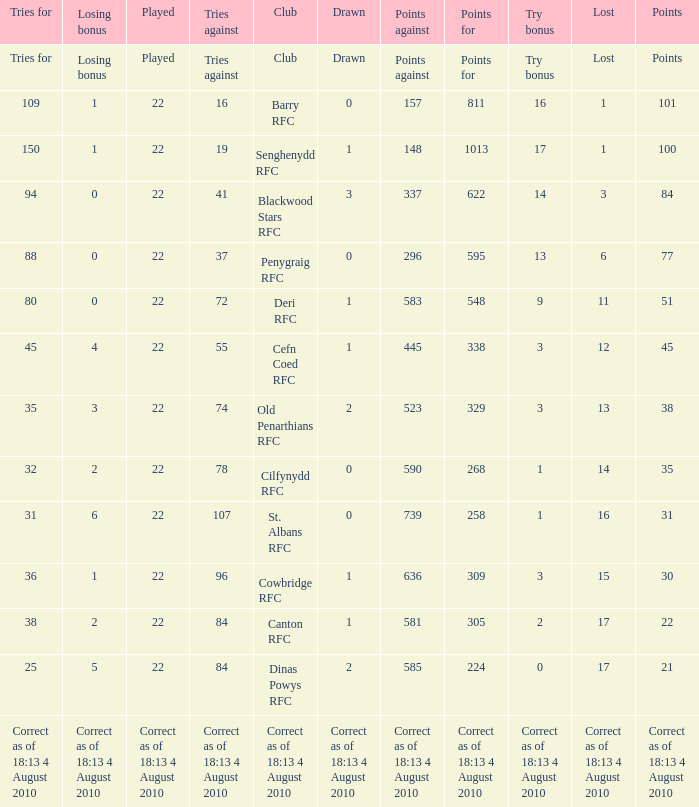What is the points when the lost was 11? 548.0. 